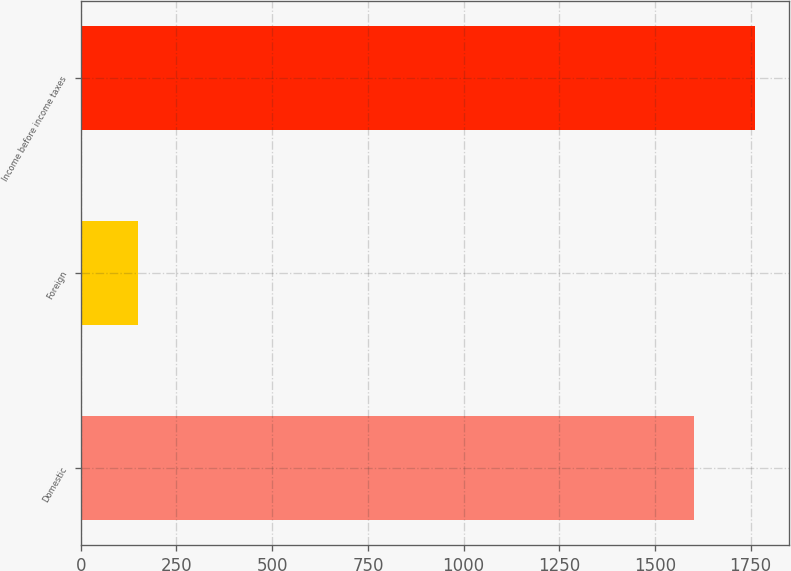<chart> <loc_0><loc_0><loc_500><loc_500><bar_chart><fcel>Domestic<fcel>Foreign<fcel>Income before income taxes<nl><fcel>1601<fcel>150<fcel>1761.1<nl></chart> 